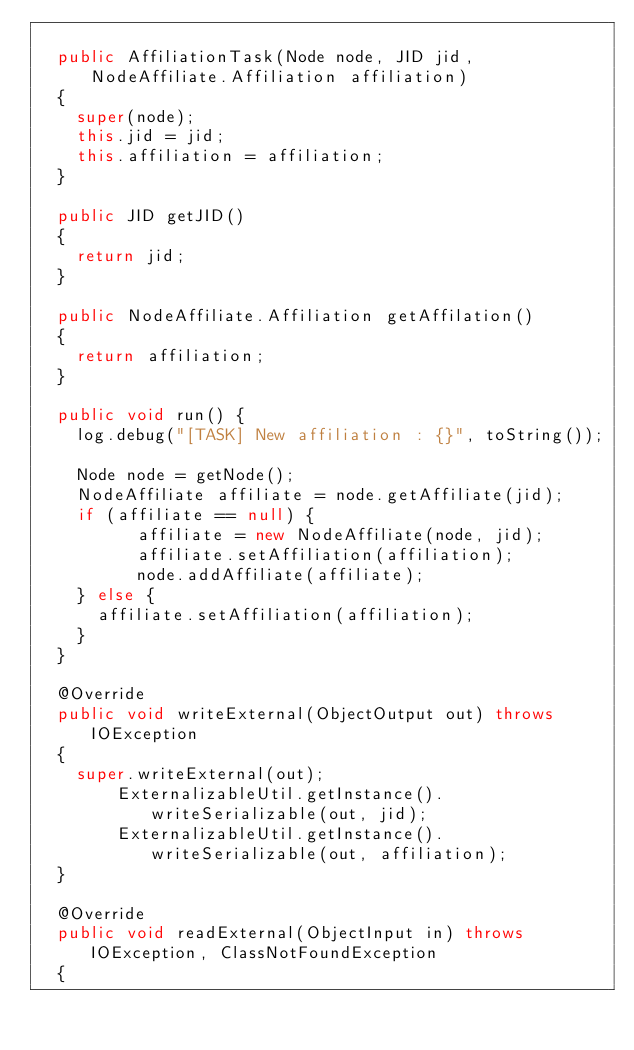<code> <loc_0><loc_0><loc_500><loc_500><_Java_>
	public AffiliationTask(Node node, JID jid, NodeAffiliate.Affiliation affiliation)
	{
		super(node);
		this.jid = jid;
		this.affiliation = affiliation;
	}

	public JID getJID()
	{
		return jid;
	}

	public NodeAffiliate.Affiliation getAffilation()
	{
		return affiliation;
	}
	
	public void run() {
		log.debug("[TASK] New affiliation : {}", toString());

		Node node = getNode();
		NodeAffiliate affiliate = node.getAffiliate(jid);
		if (affiliate == null) {
        	affiliate = new NodeAffiliate(node, jid);
        	affiliate.setAffiliation(affiliation);
        	node.addAffiliate(affiliate);
		} else {
			affiliate.setAffiliation(affiliation);
		}
	}

	@Override
	public void writeExternal(ObjectOutput out) throws IOException
	{
		super.writeExternal(out);
        ExternalizableUtil.getInstance().writeSerializable(out, jid);
        ExternalizableUtil.getInstance().writeSerializable(out, affiliation);
	}

	@Override
	public void readExternal(ObjectInput in) throws IOException, ClassNotFoundException
	{</code> 